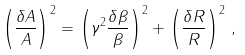Convert formula to latex. <formula><loc_0><loc_0><loc_500><loc_500>\left ( \frac { \delta A } { A } \right ) ^ { 2 } = \left ( \gamma ^ { 2 } \frac { \delta \beta } { \beta } \right ) ^ { 2 } + \left ( \frac { \delta R } { R } \right ) ^ { 2 } \, ,</formula> 